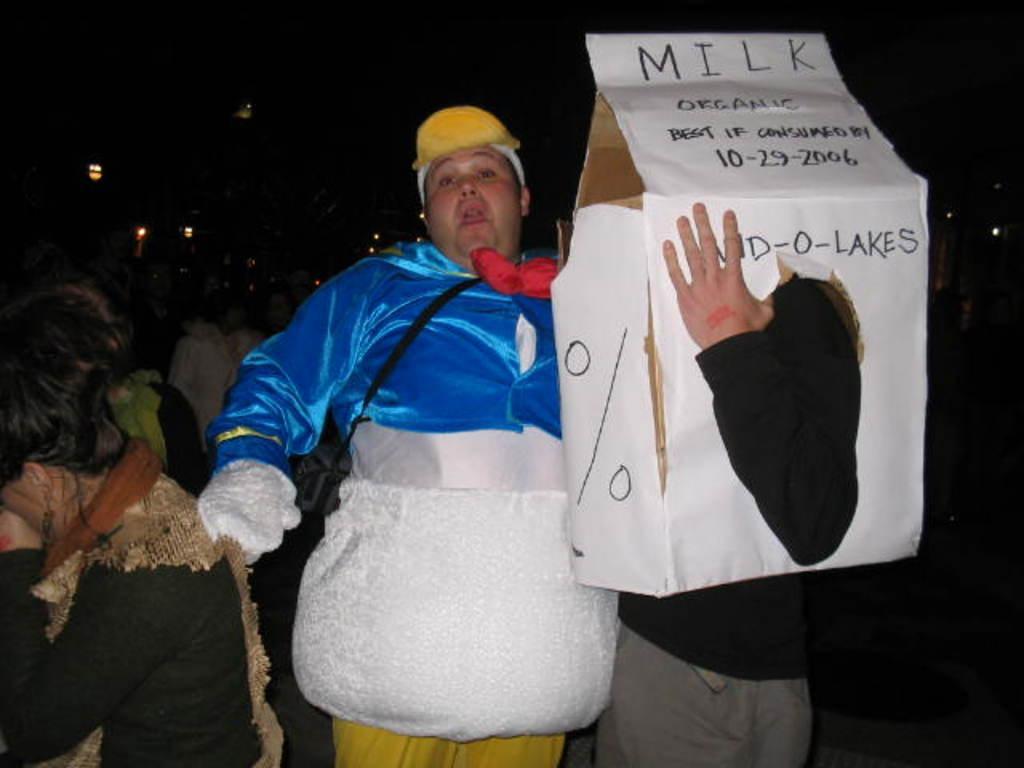Can you describe this image briefly? This is an image clicked in the dark. Here I can see a person wearing the costume, standing and holding an object in the hand. Beside him there is another person holding a card box. In the background, I can see some other people in the dark. 